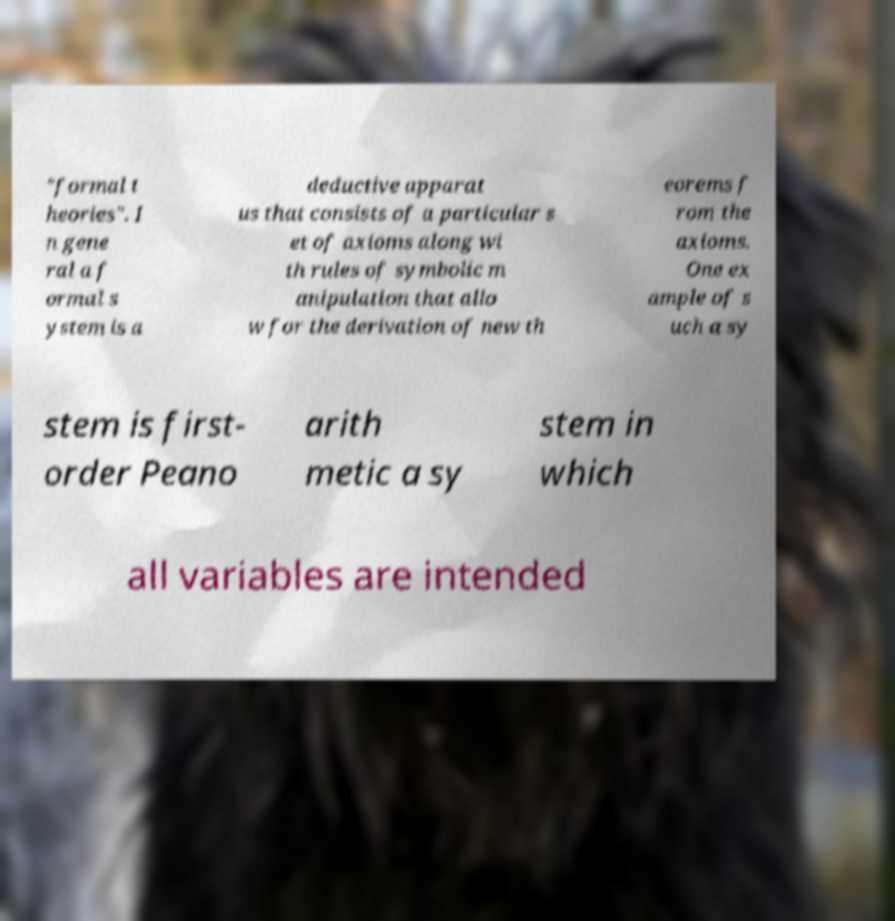I need the written content from this picture converted into text. Can you do that? "formal t heories". I n gene ral a f ormal s ystem is a deductive apparat us that consists of a particular s et of axioms along wi th rules of symbolic m anipulation that allo w for the derivation of new th eorems f rom the axioms. One ex ample of s uch a sy stem is first- order Peano arith metic a sy stem in which all variables are intended 